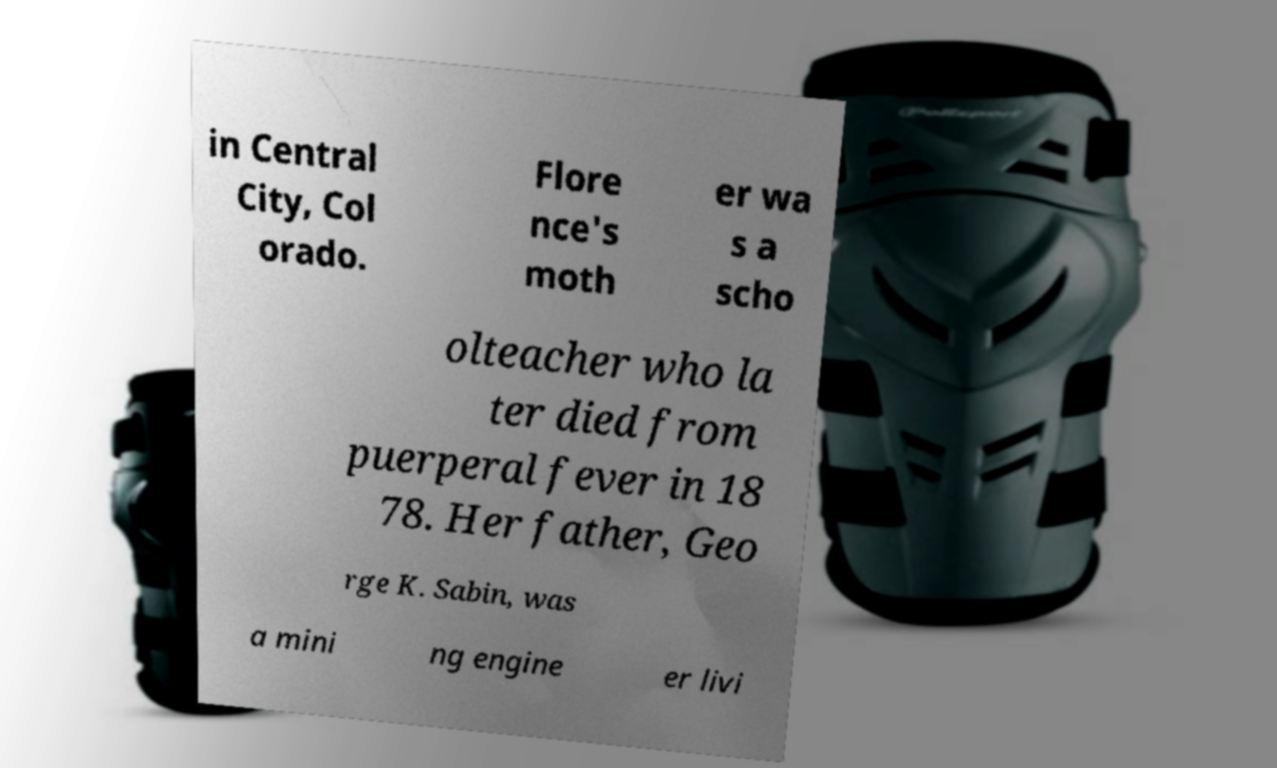For documentation purposes, I need the text within this image transcribed. Could you provide that? in Central City, Col orado. Flore nce's moth er wa s a scho olteacher who la ter died from puerperal fever in 18 78. Her father, Geo rge K. Sabin, was a mini ng engine er livi 